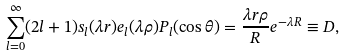<formula> <loc_0><loc_0><loc_500><loc_500>\sum _ { l = 0 } ^ { \infty } ( 2 l + 1 ) s _ { l } ( \lambda r ) e _ { l } ( \lambda \rho ) P _ { l } ( \cos \theta ) = \frac { \lambda r \rho } { R } e ^ { - \lambda R } \equiv D ,</formula> 